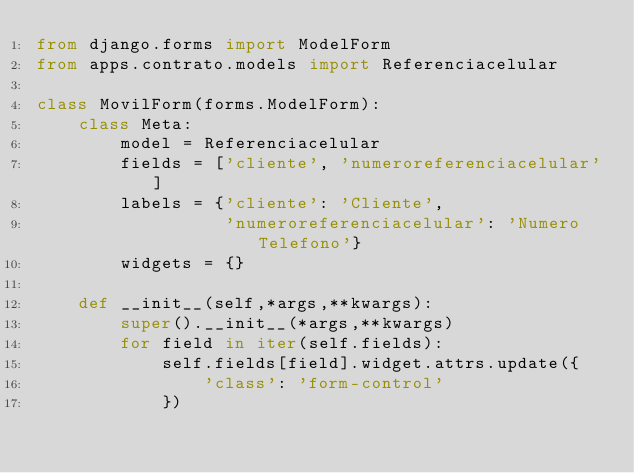Convert code to text. <code><loc_0><loc_0><loc_500><loc_500><_Python_>from django.forms import ModelForm
from apps.contrato.models import Referenciacelular

class MovilForm(forms.ModelForm):
    class Meta:
        model = Referenciacelular
        fields = ['cliente', 'numeroreferenciacelular']
        labels = {'cliente': 'Cliente',
                  'numeroreferenciacelular': 'Numero Telefono'}
        widgets = {}

    def __init__(self,*args,**kwargs):
        super().__init__(*args,**kwargs)
        for field in iter(self.fields):
            self.fields[field].widget.attrs.update({
                'class': 'form-control'
            })</code> 